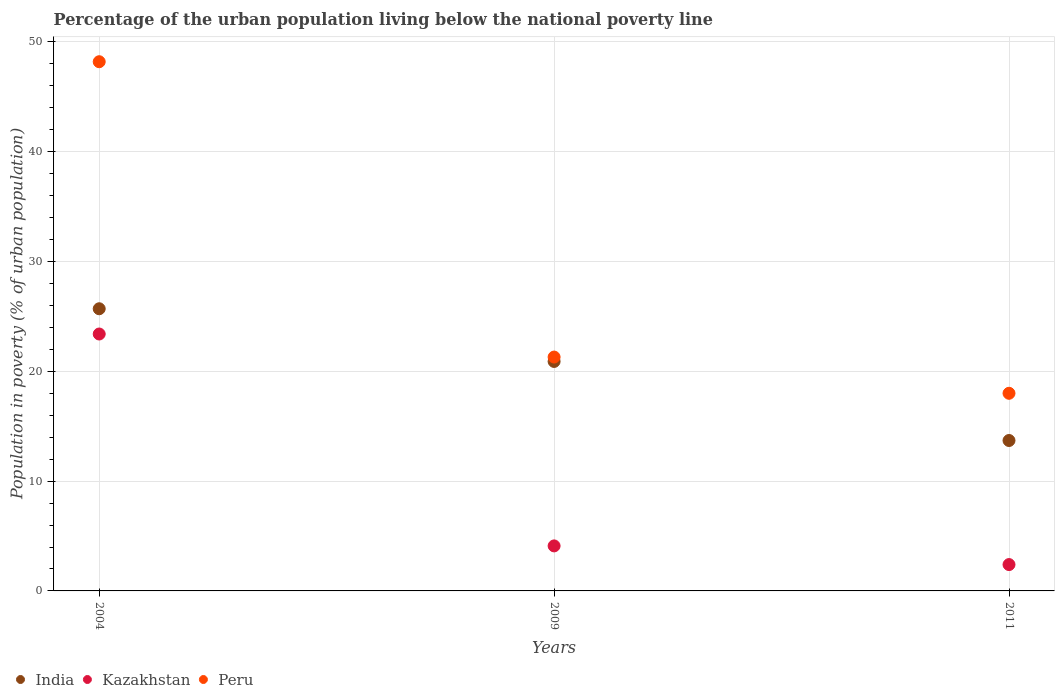What is the percentage of the urban population living below the national poverty line in Peru in 2009?
Offer a very short reply. 21.3. Across all years, what is the maximum percentage of the urban population living below the national poverty line in Peru?
Your response must be concise. 48.2. What is the total percentage of the urban population living below the national poverty line in Kazakhstan in the graph?
Keep it short and to the point. 29.9. What is the difference between the percentage of the urban population living below the national poverty line in Peru in 2004 and that in 2009?
Give a very brief answer. 26.9. What is the average percentage of the urban population living below the national poverty line in Kazakhstan per year?
Your answer should be very brief. 9.97. In the year 2004, what is the difference between the percentage of the urban population living below the national poverty line in Kazakhstan and percentage of the urban population living below the national poverty line in India?
Give a very brief answer. -2.3. What is the ratio of the percentage of the urban population living below the national poverty line in Peru in 2009 to that in 2011?
Keep it short and to the point. 1.18. Is the percentage of the urban population living below the national poverty line in India in 2004 less than that in 2011?
Your response must be concise. No. What is the difference between the highest and the second highest percentage of the urban population living below the national poverty line in Kazakhstan?
Give a very brief answer. 19.3. What is the difference between the highest and the lowest percentage of the urban population living below the national poverty line in Kazakhstan?
Your response must be concise. 21. Does the percentage of the urban population living below the national poverty line in Kazakhstan monotonically increase over the years?
Provide a short and direct response. No. Is the percentage of the urban population living below the national poverty line in Kazakhstan strictly greater than the percentage of the urban population living below the national poverty line in India over the years?
Offer a terse response. No. Is the percentage of the urban population living below the national poverty line in India strictly less than the percentage of the urban population living below the national poverty line in Kazakhstan over the years?
Keep it short and to the point. No. How many dotlines are there?
Make the answer very short. 3. Does the graph contain any zero values?
Your response must be concise. No. Does the graph contain grids?
Your response must be concise. Yes. Where does the legend appear in the graph?
Your answer should be compact. Bottom left. What is the title of the graph?
Your answer should be very brief. Percentage of the urban population living below the national poverty line. What is the label or title of the X-axis?
Provide a short and direct response. Years. What is the label or title of the Y-axis?
Provide a succinct answer. Population in poverty (% of urban population). What is the Population in poverty (% of urban population) in India in 2004?
Your answer should be very brief. 25.7. What is the Population in poverty (% of urban population) in Kazakhstan in 2004?
Your response must be concise. 23.4. What is the Population in poverty (% of urban population) of Peru in 2004?
Provide a succinct answer. 48.2. What is the Population in poverty (% of urban population) of India in 2009?
Ensure brevity in your answer.  20.9. What is the Population in poverty (% of urban population) in Kazakhstan in 2009?
Your response must be concise. 4.1. What is the Population in poverty (% of urban population) in Peru in 2009?
Offer a terse response. 21.3. What is the Population in poverty (% of urban population) of India in 2011?
Make the answer very short. 13.7. Across all years, what is the maximum Population in poverty (% of urban population) of India?
Provide a short and direct response. 25.7. Across all years, what is the maximum Population in poverty (% of urban population) of Kazakhstan?
Provide a short and direct response. 23.4. Across all years, what is the maximum Population in poverty (% of urban population) of Peru?
Make the answer very short. 48.2. Across all years, what is the minimum Population in poverty (% of urban population) in India?
Offer a terse response. 13.7. Across all years, what is the minimum Population in poverty (% of urban population) in Kazakhstan?
Ensure brevity in your answer.  2.4. What is the total Population in poverty (% of urban population) of India in the graph?
Offer a terse response. 60.3. What is the total Population in poverty (% of urban population) in Kazakhstan in the graph?
Your response must be concise. 29.9. What is the total Population in poverty (% of urban population) of Peru in the graph?
Offer a very short reply. 87.5. What is the difference between the Population in poverty (% of urban population) of Kazakhstan in 2004 and that in 2009?
Your answer should be very brief. 19.3. What is the difference between the Population in poverty (% of urban population) in Peru in 2004 and that in 2009?
Your answer should be very brief. 26.9. What is the difference between the Population in poverty (% of urban population) of India in 2004 and that in 2011?
Offer a very short reply. 12. What is the difference between the Population in poverty (% of urban population) of Peru in 2004 and that in 2011?
Keep it short and to the point. 30.2. What is the difference between the Population in poverty (% of urban population) in Kazakhstan in 2009 and that in 2011?
Provide a short and direct response. 1.7. What is the difference between the Population in poverty (% of urban population) of India in 2004 and the Population in poverty (% of urban population) of Kazakhstan in 2009?
Provide a short and direct response. 21.6. What is the difference between the Population in poverty (% of urban population) in India in 2004 and the Population in poverty (% of urban population) in Peru in 2009?
Offer a terse response. 4.4. What is the difference between the Population in poverty (% of urban population) of Kazakhstan in 2004 and the Population in poverty (% of urban population) of Peru in 2009?
Make the answer very short. 2.1. What is the difference between the Population in poverty (% of urban population) of India in 2004 and the Population in poverty (% of urban population) of Kazakhstan in 2011?
Make the answer very short. 23.3. What is the difference between the Population in poverty (% of urban population) of Kazakhstan in 2004 and the Population in poverty (% of urban population) of Peru in 2011?
Provide a short and direct response. 5.4. What is the difference between the Population in poverty (% of urban population) of India in 2009 and the Population in poverty (% of urban population) of Kazakhstan in 2011?
Offer a very short reply. 18.5. What is the average Population in poverty (% of urban population) of India per year?
Provide a short and direct response. 20.1. What is the average Population in poverty (% of urban population) in Kazakhstan per year?
Ensure brevity in your answer.  9.97. What is the average Population in poverty (% of urban population) in Peru per year?
Offer a very short reply. 29.17. In the year 2004, what is the difference between the Population in poverty (% of urban population) of India and Population in poverty (% of urban population) of Kazakhstan?
Give a very brief answer. 2.3. In the year 2004, what is the difference between the Population in poverty (% of urban population) of India and Population in poverty (% of urban population) of Peru?
Ensure brevity in your answer.  -22.5. In the year 2004, what is the difference between the Population in poverty (% of urban population) in Kazakhstan and Population in poverty (% of urban population) in Peru?
Your response must be concise. -24.8. In the year 2009, what is the difference between the Population in poverty (% of urban population) in India and Population in poverty (% of urban population) in Peru?
Offer a terse response. -0.4. In the year 2009, what is the difference between the Population in poverty (% of urban population) of Kazakhstan and Population in poverty (% of urban population) of Peru?
Make the answer very short. -17.2. In the year 2011, what is the difference between the Population in poverty (% of urban population) of India and Population in poverty (% of urban population) of Peru?
Offer a very short reply. -4.3. In the year 2011, what is the difference between the Population in poverty (% of urban population) in Kazakhstan and Population in poverty (% of urban population) in Peru?
Ensure brevity in your answer.  -15.6. What is the ratio of the Population in poverty (% of urban population) in India in 2004 to that in 2009?
Keep it short and to the point. 1.23. What is the ratio of the Population in poverty (% of urban population) in Kazakhstan in 2004 to that in 2009?
Ensure brevity in your answer.  5.71. What is the ratio of the Population in poverty (% of urban population) in Peru in 2004 to that in 2009?
Your answer should be compact. 2.26. What is the ratio of the Population in poverty (% of urban population) in India in 2004 to that in 2011?
Your answer should be compact. 1.88. What is the ratio of the Population in poverty (% of urban population) of Kazakhstan in 2004 to that in 2011?
Give a very brief answer. 9.75. What is the ratio of the Population in poverty (% of urban population) in Peru in 2004 to that in 2011?
Provide a short and direct response. 2.68. What is the ratio of the Population in poverty (% of urban population) in India in 2009 to that in 2011?
Keep it short and to the point. 1.53. What is the ratio of the Population in poverty (% of urban population) in Kazakhstan in 2009 to that in 2011?
Provide a short and direct response. 1.71. What is the ratio of the Population in poverty (% of urban population) in Peru in 2009 to that in 2011?
Your response must be concise. 1.18. What is the difference between the highest and the second highest Population in poverty (% of urban population) in Kazakhstan?
Your answer should be compact. 19.3. What is the difference between the highest and the second highest Population in poverty (% of urban population) in Peru?
Your answer should be compact. 26.9. What is the difference between the highest and the lowest Population in poverty (% of urban population) in India?
Give a very brief answer. 12. What is the difference between the highest and the lowest Population in poverty (% of urban population) of Kazakhstan?
Your answer should be compact. 21. What is the difference between the highest and the lowest Population in poverty (% of urban population) of Peru?
Your response must be concise. 30.2. 